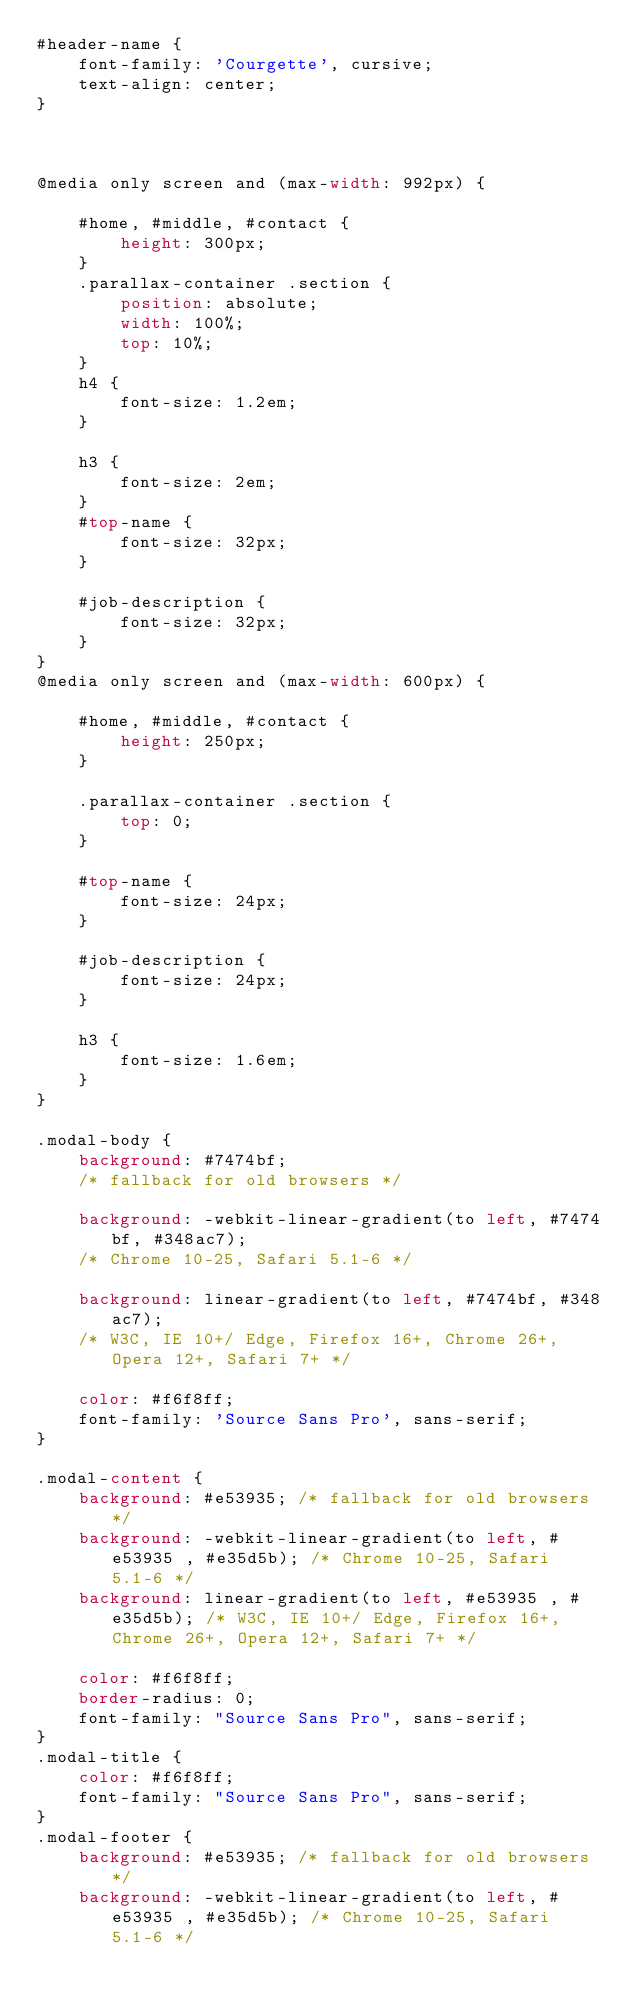<code> <loc_0><loc_0><loc_500><loc_500><_CSS_>#header-name {
    font-family: 'Courgette', cursive;
    text-align: center;
}



@media only screen and (max-width: 992px) {

    #home, #middle, #contact {
        height: 300px;
    }
    .parallax-container .section {
        position: absolute;
        width: 100%;
        top: 10%;
    }
    h4 {
        font-size: 1.2em;
    }

    h3 {
        font-size: 2em;
    }
    #top-name {
        font-size: 32px;
    }

    #job-description {
        font-size: 32px;
    }
}
@media only screen and (max-width: 600px) {

    #home, #middle, #contact {
        height: 250px;
    }

    .parallax-container .section {
        top: 0;
    }

    #top-name {
        font-size: 24px;
    }

    #job-description {
        font-size: 24px;
    }

    h3 {
        font-size: 1.6em;
    }
}

.modal-body {
    background: #7474bf;
    /* fallback for old browsers */
    
    background: -webkit-linear-gradient(to left, #7474bf, #348ac7);
    /* Chrome 10-25, Safari 5.1-6 */
    
    background: linear-gradient(to left, #7474bf, #348ac7);
    /* W3C, IE 10+/ Edge, Firefox 16+, Chrome 26+, Opera 12+, Safari 7+ */
    
    color: #f6f8ff;
    font-family: 'Source Sans Pro', sans-serif;
}

.modal-content {
    background: #e53935; /* fallback for old browsers */
    background: -webkit-linear-gradient(to left, #e53935 , #e35d5b); /* Chrome 10-25, Safari 5.1-6 */
    background: linear-gradient(to left, #e53935 , #e35d5b); /* W3C, IE 10+/ Edge, Firefox 16+, Chrome 26+, Opera 12+, Safari 7+ */
            
    color: #f6f8ff;
    border-radius: 0;
    font-family: "Source Sans Pro", sans-serif;
}
.modal-title {
    color: #f6f8ff;
    font-family: "Source Sans Pro", sans-serif;
}
.modal-footer {
    background: #e53935; /* fallback for old browsers */
    background: -webkit-linear-gradient(to left, #e53935 , #e35d5b); /* Chrome 10-25, Safari 5.1-6 */</code> 